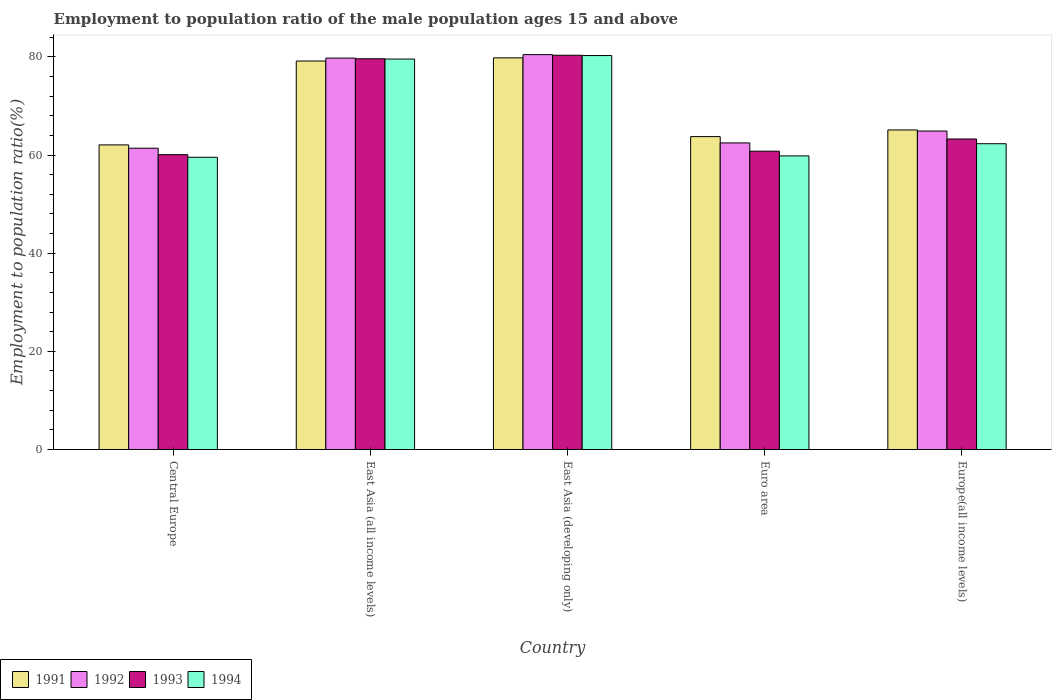How many different coloured bars are there?
Ensure brevity in your answer.  4. Are the number of bars per tick equal to the number of legend labels?
Your answer should be compact. Yes. In how many cases, is the number of bars for a given country not equal to the number of legend labels?
Offer a very short reply. 0. What is the employment to population ratio in 1993 in Euro area?
Your response must be concise. 60.78. Across all countries, what is the maximum employment to population ratio in 1994?
Provide a short and direct response. 80.26. Across all countries, what is the minimum employment to population ratio in 1991?
Provide a short and direct response. 62.06. In which country was the employment to population ratio in 1992 maximum?
Keep it short and to the point. East Asia (developing only). In which country was the employment to population ratio in 1992 minimum?
Ensure brevity in your answer.  Central Europe. What is the total employment to population ratio in 1992 in the graph?
Offer a terse response. 348.92. What is the difference between the employment to population ratio in 1994 in Central Europe and that in Euro area?
Offer a terse response. -0.28. What is the difference between the employment to population ratio in 1992 in East Asia (all income levels) and the employment to population ratio in 1991 in Central Europe?
Your response must be concise. 17.68. What is the average employment to population ratio in 1991 per country?
Give a very brief answer. 69.97. What is the difference between the employment to population ratio of/in 1991 and employment to population ratio of/in 1993 in East Asia (developing only)?
Offer a very short reply. -0.53. What is the ratio of the employment to population ratio in 1991 in East Asia (developing only) to that in Europe(all income levels)?
Your response must be concise. 1.23. Is the difference between the employment to population ratio in 1991 in East Asia (all income levels) and East Asia (developing only) greater than the difference between the employment to population ratio in 1993 in East Asia (all income levels) and East Asia (developing only)?
Offer a very short reply. Yes. What is the difference between the highest and the second highest employment to population ratio in 1991?
Provide a succinct answer. -14.04. What is the difference between the highest and the lowest employment to population ratio in 1993?
Provide a succinct answer. 20.25. Is it the case that in every country, the sum of the employment to population ratio in 1992 and employment to population ratio in 1991 is greater than the sum of employment to population ratio in 1994 and employment to population ratio in 1993?
Your answer should be very brief. No. What does the 4th bar from the left in Euro area represents?
Provide a short and direct response. 1994. Is it the case that in every country, the sum of the employment to population ratio in 1993 and employment to population ratio in 1994 is greater than the employment to population ratio in 1991?
Offer a very short reply. Yes. How many bars are there?
Provide a short and direct response. 20. Are all the bars in the graph horizontal?
Offer a very short reply. No. Are the values on the major ticks of Y-axis written in scientific E-notation?
Offer a terse response. No. What is the title of the graph?
Make the answer very short. Employment to population ratio of the male population ages 15 and above. What is the label or title of the X-axis?
Ensure brevity in your answer.  Country. What is the Employment to population ratio(%) in 1991 in Central Europe?
Offer a very short reply. 62.06. What is the Employment to population ratio(%) in 1992 in Central Europe?
Offer a very short reply. 61.38. What is the Employment to population ratio(%) in 1993 in Central Europe?
Your answer should be very brief. 60.07. What is the Employment to population ratio(%) in 1994 in Central Europe?
Offer a terse response. 59.54. What is the Employment to population ratio(%) of 1991 in East Asia (all income levels)?
Ensure brevity in your answer.  79.15. What is the Employment to population ratio(%) of 1992 in East Asia (all income levels)?
Provide a short and direct response. 79.74. What is the Employment to population ratio(%) of 1993 in East Asia (all income levels)?
Ensure brevity in your answer.  79.61. What is the Employment to population ratio(%) of 1994 in East Asia (all income levels)?
Provide a short and direct response. 79.55. What is the Employment to population ratio(%) in 1991 in East Asia (developing only)?
Offer a terse response. 79.79. What is the Employment to population ratio(%) of 1992 in East Asia (developing only)?
Give a very brief answer. 80.45. What is the Employment to population ratio(%) in 1993 in East Asia (developing only)?
Provide a succinct answer. 80.32. What is the Employment to population ratio(%) in 1994 in East Asia (developing only)?
Your answer should be compact. 80.26. What is the Employment to population ratio(%) of 1991 in Euro area?
Your answer should be compact. 63.75. What is the Employment to population ratio(%) in 1992 in Euro area?
Give a very brief answer. 62.46. What is the Employment to population ratio(%) in 1993 in Euro area?
Provide a short and direct response. 60.78. What is the Employment to population ratio(%) of 1994 in Euro area?
Provide a short and direct response. 59.81. What is the Employment to population ratio(%) in 1991 in Europe(all income levels)?
Keep it short and to the point. 65.11. What is the Employment to population ratio(%) of 1992 in Europe(all income levels)?
Keep it short and to the point. 64.88. What is the Employment to population ratio(%) of 1993 in Europe(all income levels)?
Give a very brief answer. 63.26. What is the Employment to population ratio(%) of 1994 in Europe(all income levels)?
Give a very brief answer. 62.3. Across all countries, what is the maximum Employment to population ratio(%) of 1991?
Ensure brevity in your answer.  79.79. Across all countries, what is the maximum Employment to population ratio(%) in 1992?
Your answer should be very brief. 80.45. Across all countries, what is the maximum Employment to population ratio(%) of 1993?
Your response must be concise. 80.32. Across all countries, what is the maximum Employment to population ratio(%) in 1994?
Your answer should be very brief. 80.26. Across all countries, what is the minimum Employment to population ratio(%) in 1991?
Your response must be concise. 62.06. Across all countries, what is the minimum Employment to population ratio(%) of 1992?
Keep it short and to the point. 61.38. Across all countries, what is the minimum Employment to population ratio(%) in 1993?
Your answer should be compact. 60.07. Across all countries, what is the minimum Employment to population ratio(%) of 1994?
Make the answer very short. 59.54. What is the total Employment to population ratio(%) in 1991 in the graph?
Your response must be concise. 349.86. What is the total Employment to population ratio(%) in 1992 in the graph?
Give a very brief answer. 348.92. What is the total Employment to population ratio(%) in 1993 in the graph?
Offer a very short reply. 344.05. What is the total Employment to population ratio(%) of 1994 in the graph?
Keep it short and to the point. 341.46. What is the difference between the Employment to population ratio(%) of 1991 in Central Europe and that in East Asia (all income levels)?
Offer a terse response. -17.08. What is the difference between the Employment to population ratio(%) of 1992 in Central Europe and that in East Asia (all income levels)?
Ensure brevity in your answer.  -18.36. What is the difference between the Employment to population ratio(%) of 1993 in Central Europe and that in East Asia (all income levels)?
Your answer should be very brief. -19.54. What is the difference between the Employment to population ratio(%) in 1994 in Central Europe and that in East Asia (all income levels)?
Offer a very short reply. -20.01. What is the difference between the Employment to population ratio(%) of 1991 in Central Europe and that in East Asia (developing only)?
Provide a short and direct response. -17.73. What is the difference between the Employment to population ratio(%) in 1992 in Central Europe and that in East Asia (developing only)?
Offer a terse response. -19.07. What is the difference between the Employment to population ratio(%) in 1993 in Central Europe and that in East Asia (developing only)?
Keep it short and to the point. -20.25. What is the difference between the Employment to population ratio(%) of 1994 in Central Europe and that in East Asia (developing only)?
Make the answer very short. -20.72. What is the difference between the Employment to population ratio(%) in 1991 in Central Europe and that in Euro area?
Your answer should be very brief. -1.69. What is the difference between the Employment to population ratio(%) of 1992 in Central Europe and that in Euro area?
Keep it short and to the point. -1.08. What is the difference between the Employment to population ratio(%) in 1993 in Central Europe and that in Euro area?
Offer a very short reply. -0.71. What is the difference between the Employment to population ratio(%) of 1994 in Central Europe and that in Euro area?
Offer a terse response. -0.28. What is the difference between the Employment to population ratio(%) in 1991 in Central Europe and that in Europe(all income levels)?
Your answer should be very brief. -3.04. What is the difference between the Employment to population ratio(%) in 1992 in Central Europe and that in Europe(all income levels)?
Keep it short and to the point. -3.5. What is the difference between the Employment to population ratio(%) in 1993 in Central Europe and that in Europe(all income levels)?
Your answer should be very brief. -3.19. What is the difference between the Employment to population ratio(%) of 1994 in Central Europe and that in Europe(all income levels)?
Give a very brief answer. -2.76. What is the difference between the Employment to population ratio(%) of 1991 in East Asia (all income levels) and that in East Asia (developing only)?
Your answer should be compact. -0.65. What is the difference between the Employment to population ratio(%) of 1992 in East Asia (all income levels) and that in East Asia (developing only)?
Give a very brief answer. -0.71. What is the difference between the Employment to population ratio(%) of 1993 in East Asia (all income levels) and that in East Asia (developing only)?
Ensure brevity in your answer.  -0.72. What is the difference between the Employment to population ratio(%) in 1994 in East Asia (all income levels) and that in East Asia (developing only)?
Offer a terse response. -0.71. What is the difference between the Employment to population ratio(%) in 1991 in East Asia (all income levels) and that in Euro area?
Your answer should be very brief. 15.4. What is the difference between the Employment to population ratio(%) in 1992 in East Asia (all income levels) and that in Euro area?
Offer a terse response. 17.28. What is the difference between the Employment to population ratio(%) of 1993 in East Asia (all income levels) and that in Euro area?
Offer a very short reply. 18.83. What is the difference between the Employment to population ratio(%) in 1994 in East Asia (all income levels) and that in Euro area?
Ensure brevity in your answer.  19.73. What is the difference between the Employment to population ratio(%) of 1991 in East Asia (all income levels) and that in Europe(all income levels)?
Provide a succinct answer. 14.04. What is the difference between the Employment to population ratio(%) in 1992 in East Asia (all income levels) and that in Europe(all income levels)?
Provide a short and direct response. 14.86. What is the difference between the Employment to population ratio(%) in 1993 in East Asia (all income levels) and that in Europe(all income levels)?
Ensure brevity in your answer.  16.34. What is the difference between the Employment to population ratio(%) in 1994 in East Asia (all income levels) and that in Europe(all income levels)?
Give a very brief answer. 17.25. What is the difference between the Employment to population ratio(%) of 1991 in East Asia (developing only) and that in Euro area?
Provide a succinct answer. 16.05. What is the difference between the Employment to population ratio(%) in 1992 in East Asia (developing only) and that in Euro area?
Provide a succinct answer. 17.99. What is the difference between the Employment to population ratio(%) of 1993 in East Asia (developing only) and that in Euro area?
Provide a short and direct response. 19.54. What is the difference between the Employment to population ratio(%) of 1994 in East Asia (developing only) and that in Euro area?
Keep it short and to the point. 20.45. What is the difference between the Employment to population ratio(%) of 1991 in East Asia (developing only) and that in Europe(all income levels)?
Offer a terse response. 14.69. What is the difference between the Employment to population ratio(%) of 1992 in East Asia (developing only) and that in Europe(all income levels)?
Offer a very short reply. 15.57. What is the difference between the Employment to population ratio(%) in 1993 in East Asia (developing only) and that in Europe(all income levels)?
Your answer should be very brief. 17.06. What is the difference between the Employment to population ratio(%) in 1994 in East Asia (developing only) and that in Europe(all income levels)?
Ensure brevity in your answer.  17.96. What is the difference between the Employment to population ratio(%) of 1991 in Euro area and that in Europe(all income levels)?
Give a very brief answer. -1.36. What is the difference between the Employment to population ratio(%) in 1992 in Euro area and that in Europe(all income levels)?
Your response must be concise. -2.42. What is the difference between the Employment to population ratio(%) in 1993 in Euro area and that in Europe(all income levels)?
Keep it short and to the point. -2.48. What is the difference between the Employment to population ratio(%) in 1994 in Euro area and that in Europe(all income levels)?
Your response must be concise. -2.49. What is the difference between the Employment to population ratio(%) in 1991 in Central Europe and the Employment to population ratio(%) in 1992 in East Asia (all income levels)?
Your response must be concise. -17.68. What is the difference between the Employment to population ratio(%) of 1991 in Central Europe and the Employment to population ratio(%) of 1993 in East Asia (all income levels)?
Make the answer very short. -17.55. What is the difference between the Employment to population ratio(%) in 1991 in Central Europe and the Employment to population ratio(%) in 1994 in East Asia (all income levels)?
Your answer should be very brief. -17.49. What is the difference between the Employment to population ratio(%) in 1992 in Central Europe and the Employment to population ratio(%) in 1993 in East Asia (all income levels)?
Ensure brevity in your answer.  -18.22. What is the difference between the Employment to population ratio(%) in 1992 in Central Europe and the Employment to population ratio(%) in 1994 in East Asia (all income levels)?
Offer a terse response. -18.16. What is the difference between the Employment to population ratio(%) of 1993 in Central Europe and the Employment to population ratio(%) of 1994 in East Asia (all income levels)?
Offer a very short reply. -19.48. What is the difference between the Employment to population ratio(%) in 1991 in Central Europe and the Employment to population ratio(%) in 1992 in East Asia (developing only)?
Ensure brevity in your answer.  -18.39. What is the difference between the Employment to population ratio(%) in 1991 in Central Europe and the Employment to population ratio(%) in 1993 in East Asia (developing only)?
Ensure brevity in your answer.  -18.26. What is the difference between the Employment to population ratio(%) of 1991 in Central Europe and the Employment to population ratio(%) of 1994 in East Asia (developing only)?
Your answer should be compact. -18.2. What is the difference between the Employment to population ratio(%) of 1992 in Central Europe and the Employment to population ratio(%) of 1993 in East Asia (developing only)?
Provide a succinct answer. -18.94. What is the difference between the Employment to population ratio(%) in 1992 in Central Europe and the Employment to population ratio(%) in 1994 in East Asia (developing only)?
Provide a short and direct response. -18.88. What is the difference between the Employment to population ratio(%) in 1993 in Central Europe and the Employment to population ratio(%) in 1994 in East Asia (developing only)?
Ensure brevity in your answer.  -20.19. What is the difference between the Employment to population ratio(%) of 1991 in Central Europe and the Employment to population ratio(%) of 1992 in Euro area?
Give a very brief answer. -0.4. What is the difference between the Employment to population ratio(%) of 1991 in Central Europe and the Employment to population ratio(%) of 1993 in Euro area?
Offer a terse response. 1.28. What is the difference between the Employment to population ratio(%) of 1991 in Central Europe and the Employment to population ratio(%) of 1994 in Euro area?
Keep it short and to the point. 2.25. What is the difference between the Employment to population ratio(%) of 1992 in Central Europe and the Employment to population ratio(%) of 1993 in Euro area?
Provide a succinct answer. 0.6. What is the difference between the Employment to population ratio(%) in 1992 in Central Europe and the Employment to population ratio(%) in 1994 in Euro area?
Make the answer very short. 1.57. What is the difference between the Employment to population ratio(%) of 1993 in Central Europe and the Employment to population ratio(%) of 1994 in Euro area?
Your response must be concise. 0.26. What is the difference between the Employment to population ratio(%) in 1991 in Central Europe and the Employment to population ratio(%) in 1992 in Europe(all income levels)?
Give a very brief answer. -2.82. What is the difference between the Employment to population ratio(%) in 1991 in Central Europe and the Employment to population ratio(%) in 1993 in Europe(all income levels)?
Your answer should be very brief. -1.2. What is the difference between the Employment to population ratio(%) in 1991 in Central Europe and the Employment to population ratio(%) in 1994 in Europe(all income levels)?
Offer a terse response. -0.24. What is the difference between the Employment to population ratio(%) of 1992 in Central Europe and the Employment to population ratio(%) of 1993 in Europe(all income levels)?
Provide a short and direct response. -1.88. What is the difference between the Employment to population ratio(%) in 1992 in Central Europe and the Employment to population ratio(%) in 1994 in Europe(all income levels)?
Give a very brief answer. -0.92. What is the difference between the Employment to population ratio(%) in 1993 in Central Europe and the Employment to population ratio(%) in 1994 in Europe(all income levels)?
Provide a short and direct response. -2.23. What is the difference between the Employment to population ratio(%) of 1991 in East Asia (all income levels) and the Employment to population ratio(%) of 1992 in East Asia (developing only)?
Your answer should be compact. -1.3. What is the difference between the Employment to population ratio(%) in 1991 in East Asia (all income levels) and the Employment to population ratio(%) in 1993 in East Asia (developing only)?
Ensure brevity in your answer.  -1.18. What is the difference between the Employment to population ratio(%) in 1991 in East Asia (all income levels) and the Employment to population ratio(%) in 1994 in East Asia (developing only)?
Your answer should be compact. -1.11. What is the difference between the Employment to population ratio(%) of 1992 in East Asia (all income levels) and the Employment to population ratio(%) of 1993 in East Asia (developing only)?
Give a very brief answer. -0.58. What is the difference between the Employment to population ratio(%) in 1992 in East Asia (all income levels) and the Employment to population ratio(%) in 1994 in East Asia (developing only)?
Your response must be concise. -0.52. What is the difference between the Employment to population ratio(%) in 1993 in East Asia (all income levels) and the Employment to population ratio(%) in 1994 in East Asia (developing only)?
Offer a very short reply. -0.65. What is the difference between the Employment to population ratio(%) of 1991 in East Asia (all income levels) and the Employment to population ratio(%) of 1992 in Euro area?
Give a very brief answer. 16.68. What is the difference between the Employment to population ratio(%) of 1991 in East Asia (all income levels) and the Employment to population ratio(%) of 1993 in Euro area?
Your answer should be very brief. 18.37. What is the difference between the Employment to population ratio(%) in 1991 in East Asia (all income levels) and the Employment to population ratio(%) in 1994 in Euro area?
Your answer should be compact. 19.33. What is the difference between the Employment to population ratio(%) of 1992 in East Asia (all income levels) and the Employment to population ratio(%) of 1993 in Euro area?
Keep it short and to the point. 18.96. What is the difference between the Employment to population ratio(%) of 1992 in East Asia (all income levels) and the Employment to population ratio(%) of 1994 in Euro area?
Keep it short and to the point. 19.93. What is the difference between the Employment to population ratio(%) of 1993 in East Asia (all income levels) and the Employment to population ratio(%) of 1994 in Euro area?
Make the answer very short. 19.79. What is the difference between the Employment to population ratio(%) of 1991 in East Asia (all income levels) and the Employment to population ratio(%) of 1992 in Europe(all income levels)?
Offer a terse response. 14.26. What is the difference between the Employment to population ratio(%) of 1991 in East Asia (all income levels) and the Employment to population ratio(%) of 1993 in Europe(all income levels)?
Keep it short and to the point. 15.88. What is the difference between the Employment to population ratio(%) in 1991 in East Asia (all income levels) and the Employment to population ratio(%) in 1994 in Europe(all income levels)?
Give a very brief answer. 16.85. What is the difference between the Employment to population ratio(%) of 1992 in East Asia (all income levels) and the Employment to population ratio(%) of 1993 in Europe(all income levels)?
Ensure brevity in your answer.  16.48. What is the difference between the Employment to population ratio(%) in 1992 in East Asia (all income levels) and the Employment to population ratio(%) in 1994 in Europe(all income levels)?
Your response must be concise. 17.44. What is the difference between the Employment to population ratio(%) of 1993 in East Asia (all income levels) and the Employment to population ratio(%) of 1994 in Europe(all income levels)?
Provide a short and direct response. 17.31. What is the difference between the Employment to population ratio(%) in 1991 in East Asia (developing only) and the Employment to population ratio(%) in 1992 in Euro area?
Your response must be concise. 17.33. What is the difference between the Employment to population ratio(%) of 1991 in East Asia (developing only) and the Employment to population ratio(%) of 1993 in Euro area?
Offer a very short reply. 19.01. What is the difference between the Employment to population ratio(%) of 1991 in East Asia (developing only) and the Employment to population ratio(%) of 1994 in Euro area?
Provide a succinct answer. 19.98. What is the difference between the Employment to population ratio(%) in 1992 in East Asia (developing only) and the Employment to population ratio(%) in 1993 in Euro area?
Offer a terse response. 19.67. What is the difference between the Employment to population ratio(%) in 1992 in East Asia (developing only) and the Employment to population ratio(%) in 1994 in Euro area?
Provide a short and direct response. 20.64. What is the difference between the Employment to population ratio(%) in 1993 in East Asia (developing only) and the Employment to population ratio(%) in 1994 in Euro area?
Offer a very short reply. 20.51. What is the difference between the Employment to population ratio(%) in 1991 in East Asia (developing only) and the Employment to population ratio(%) in 1992 in Europe(all income levels)?
Ensure brevity in your answer.  14.91. What is the difference between the Employment to population ratio(%) in 1991 in East Asia (developing only) and the Employment to population ratio(%) in 1993 in Europe(all income levels)?
Make the answer very short. 16.53. What is the difference between the Employment to population ratio(%) in 1991 in East Asia (developing only) and the Employment to population ratio(%) in 1994 in Europe(all income levels)?
Your answer should be compact. 17.49. What is the difference between the Employment to population ratio(%) of 1992 in East Asia (developing only) and the Employment to population ratio(%) of 1993 in Europe(all income levels)?
Offer a terse response. 17.19. What is the difference between the Employment to population ratio(%) of 1992 in East Asia (developing only) and the Employment to population ratio(%) of 1994 in Europe(all income levels)?
Offer a terse response. 18.15. What is the difference between the Employment to population ratio(%) in 1993 in East Asia (developing only) and the Employment to population ratio(%) in 1994 in Europe(all income levels)?
Your answer should be very brief. 18.02. What is the difference between the Employment to population ratio(%) in 1991 in Euro area and the Employment to population ratio(%) in 1992 in Europe(all income levels)?
Your answer should be very brief. -1.14. What is the difference between the Employment to population ratio(%) of 1991 in Euro area and the Employment to population ratio(%) of 1993 in Europe(all income levels)?
Provide a short and direct response. 0.48. What is the difference between the Employment to population ratio(%) in 1991 in Euro area and the Employment to population ratio(%) in 1994 in Europe(all income levels)?
Your response must be concise. 1.45. What is the difference between the Employment to population ratio(%) of 1992 in Euro area and the Employment to population ratio(%) of 1993 in Europe(all income levels)?
Your answer should be very brief. -0.8. What is the difference between the Employment to population ratio(%) of 1992 in Euro area and the Employment to population ratio(%) of 1994 in Europe(all income levels)?
Keep it short and to the point. 0.16. What is the difference between the Employment to population ratio(%) of 1993 in Euro area and the Employment to population ratio(%) of 1994 in Europe(all income levels)?
Give a very brief answer. -1.52. What is the average Employment to population ratio(%) in 1991 per country?
Ensure brevity in your answer.  69.97. What is the average Employment to population ratio(%) in 1992 per country?
Make the answer very short. 69.78. What is the average Employment to population ratio(%) of 1993 per country?
Keep it short and to the point. 68.81. What is the average Employment to population ratio(%) of 1994 per country?
Your answer should be very brief. 68.29. What is the difference between the Employment to population ratio(%) in 1991 and Employment to population ratio(%) in 1992 in Central Europe?
Give a very brief answer. 0.68. What is the difference between the Employment to population ratio(%) in 1991 and Employment to population ratio(%) in 1993 in Central Europe?
Your answer should be compact. 1.99. What is the difference between the Employment to population ratio(%) of 1991 and Employment to population ratio(%) of 1994 in Central Europe?
Make the answer very short. 2.52. What is the difference between the Employment to population ratio(%) in 1992 and Employment to population ratio(%) in 1993 in Central Europe?
Provide a succinct answer. 1.31. What is the difference between the Employment to population ratio(%) of 1992 and Employment to population ratio(%) of 1994 in Central Europe?
Your answer should be very brief. 1.85. What is the difference between the Employment to population ratio(%) in 1993 and Employment to population ratio(%) in 1994 in Central Europe?
Provide a short and direct response. 0.53. What is the difference between the Employment to population ratio(%) in 1991 and Employment to population ratio(%) in 1992 in East Asia (all income levels)?
Make the answer very short. -0.59. What is the difference between the Employment to population ratio(%) of 1991 and Employment to population ratio(%) of 1993 in East Asia (all income levels)?
Provide a succinct answer. -0.46. What is the difference between the Employment to population ratio(%) in 1991 and Employment to population ratio(%) in 1994 in East Asia (all income levels)?
Make the answer very short. -0.4. What is the difference between the Employment to population ratio(%) in 1992 and Employment to population ratio(%) in 1993 in East Asia (all income levels)?
Your response must be concise. 0.13. What is the difference between the Employment to population ratio(%) of 1992 and Employment to population ratio(%) of 1994 in East Asia (all income levels)?
Your answer should be very brief. 0.19. What is the difference between the Employment to population ratio(%) of 1993 and Employment to population ratio(%) of 1994 in East Asia (all income levels)?
Provide a short and direct response. 0.06. What is the difference between the Employment to population ratio(%) of 1991 and Employment to population ratio(%) of 1992 in East Asia (developing only)?
Your response must be concise. -0.66. What is the difference between the Employment to population ratio(%) of 1991 and Employment to population ratio(%) of 1993 in East Asia (developing only)?
Make the answer very short. -0.53. What is the difference between the Employment to population ratio(%) of 1991 and Employment to population ratio(%) of 1994 in East Asia (developing only)?
Give a very brief answer. -0.47. What is the difference between the Employment to population ratio(%) in 1992 and Employment to population ratio(%) in 1993 in East Asia (developing only)?
Your answer should be very brief. 0.13. What is the difference between the Employment to population ratio(%) in 1992 and Employment to population ratio(%) in 1994 in East Asia (developing only)?
Offer a terse response. 0.19. What is the difference between the Employment to population ratio(%) in 1993 and Employment to population ratio(%) in 1994 in East Asia (developing only)?
Offer a very short reply. 0.06. What is the difference between the Employment to population ratio(%) of 1991 and Employment to population ratio(%) of 1992 in Euro area?
Your response must be concise. 1.29. What is the difference between the Employment to population ratio(%) in 1991 and Employment to population ratio(%) in 1993 in Euro area?
Provide a succinct answer. 2.97. What is the difference between the Employment to population ratio(%) in 1991 and Employment to population ratio(%) in 1994 in Euro area?
Offer a terse response. 3.93. What is the difference between the Employment to population ratio(%) of 1992 and Employment to population ratio(%) of 1993 in Euro area?
Offer a terse response. 1.68. What is the difference between the Employment to population ratio(%) of 1992 and Employment to population ratio(%) of 1994 in Euro area?
Your answer should be compact. 2.65. What is the difference between the Employment to population ratio(%) of 1993 and Employment to population ratio(%) of 1994 in Euro area?
Your response must be concise. 0.97. What is the difference between the Employment to population ratio(%) in 1991 and Employment to population ratio(%) in 1992 in Europe(all income levels)?
Provide a short and direct response. 0.22. What is the difference between the Employment to population ratio(%) in 1991 and Employment to population ratio(%) in 1993 in Europe(all income levels)?
Your response must be concise. 1.84. What is the difference between the Employment to population ratio(%) of 1991 and Employment to population ratio(%) of 1994 in Europe(all income levels)?
Make the answer very short. 2.81. What is the difference between the Employment to population ratio(%) of 1992 and Employment to population ratio(%) of 1993 in Europe(all income levels)?
Give a very brief answer. 1.62. What is the difference between the Employment to population ratio(%) in 1992 and Employment to population ratio(%) in 1994 in Europe(all income levels)?
Keep it short and to the point. 2.58. What is the difference between the Employment to population ratio(%) in 1993 and Employment to population ratio(%) in 1994 in Europe(all income levels)?
Offer a very short reply. 0.97. What is the ratio of the Employment to population ratio(%) in 1991 in Central Europe to that in East Asia (all income levels)?
Ensure brevity in your answer.  0.78. What is the ratio of the Employment to population ratio(%) in 1992 in Central Europe to that in East Asia (all income levels)?
Make the answer very short. 0.77. What is the ratio of the Employment to population ratio(%) of 1993 in Central Europe to that in East Asia (all income levels)?
Ensure brevity in your answer.  0.75. What is the ratio of the Employment to population ratio(%) of 1994 in Central Europe to that in East Asia (all income levels)?
Your answer should be very brief. 0.75. What is the ratio of the Employment to population ratio(%) in 1991 in Central Europe to that in East Asia (developing only)?
Provide a short and direct response. 0.78. What is the ratio of the Employment to population ratio(%) in 1992 in Central Europe to that in East Asia (developing only)?
Provide a short and direct response. 0.76. What is the ratio of the Employment to population ratio(%) of 1993 in Central Europe to that in East Asia (developing only)?
Offer a terse response. 0.75. What is the ratio of the Employment to population ratio(%) of 1994 in Central Europe to that in East Asia (developing only)?
Your answer should be compact. 0.74. What is the ratio of the Employment to population ratio(%) in 1991 in Central Europe to that in Euro area?
Provide a succinct answer. 0.97. What is the ratio of the Employment to population ratio(%) in 1992 in Central Europe to that in Euro area?
Your response must be concise. 0.98. What is the ratio of the Employment to population ratio(%) of 1993 in Central Europe to that in Euro area?
Provide a succinct answer. 0.99. What is the ratio of the Employment to population ratio(%) in 1991 in Central Europe to that in Europe(all income levels)?
Provide a succinct answer. 0.95. What is the ratio of the Employment to population ratio(%) in 1992 in Central Europe to that in Europe(all income levels)?
Your answer should be very brief. 0.95. What is the ratio of the Employment to population ratio(%) in 1993 in Central Europe to that in Europe(all income levels)?
Ensure brevity in your answer.  0.95. What is the ratio of the Employment to population ratio(%) in 1994 in Central Europe to that in Europe(all income levels)?
Provide a succinct answer. 0.96. What is the ratio of the Employment to population ratio(%) of 1991 in East Asia (all income levels) to that in East Asia (developing only)?
Give a very brief answer. 0.99. What is the ratio of the Employment to population ratio(%) in 1992 in East Asia (all income levels) to that in East Asia (developing only)?
Make the answer very short. 0.99. What is the ratio of the Employment to population ratio(%) in 1993 in East Asia (all income levels) to that in East Asia (developing only)?
Your answer should be very brief. 0.99. What is the ratio of the Employment to population ratio(%) in 1991 in East Asia (all income levels) to that in Euro area?
Offer a terse response. 1.24. What is the ratio of the Employment to population ratio(%) in 1992 in East Asia (all income levels) to that in Euro area?
Give a very brief answer. 1.28. What is the ratio of the Employment to population ratio(%) in 1993 in East Asia (all income levels) to that in Euro area?
Offer a very short reply. 1.31. What is the ratio of the Employment to population ratio(%) in 1994 in East Asia (all income levels) to that in Euro area?
Ensure brevity in your answer.  1.33. What is the ratio of the Employment to population ratio(%) in 1991 in East Asia (all income levels) to that in Europe(all income levels)?
Your response must be concise. 1.22. What is the ratio of the Employment to population ratio(%) of 1992 in East Asia (all income levels) to that in Europe(all income levels)?
Ensure brevity in your answer.  1.23. What is the ratio of the Employment to population ratio(%) in 1993 in East Asia (all income levels) to that in Europe(all income levels)?
Offer a very short reply. 1.26. What is the ratio of the Employment to population ratio(%) of 1994 in East Asia (all income levels) to that in Europe(all income levels)?
Ensure brevity in your answer.  1.28. What is the ratio of the Employment to population ratio(%) in 1991 in East Asia (developing only) to that in Euro area?
Keep it short and to the point. 1.25. What is the ratio of the Employment to population ratio(%) of 1992 in East Asia (developing only) to that in Euro area?
Make the answer very short. 1.29. What is the ratio of the Employment to population ratio(%) in 1993 in East Asia (developing only) to that in Euro area?
Provide a succinct answer. 1.32. What is the ratio of the Employment to population ratio(%) in 1994 in East Asia (developing only) to that in Euro area?
Your response must be concise. 1.34. What is the ratio of the Employment to population ratio(%) of 1991 in East Asia (developing only) to that in Europe(all income levels)?
Your response must be concise. 1.23. What is the ratio of the Employment to population ratio(%) in 1992 in East Asia (developing only) to that in Europe(all income levels)?
Offer a terse response. 1.24. What is the ratio of the Employment to population ratio(%) of 1993 in East Asia (developing only) to that in Europe(all income levels)?
Your response must be concise. 1.27. What is the ratio of the Employment to population ratio(%) in 1994 in East Asia (developing only) to that in Europe(all income levels)?
Your response must be concise. 1.29. What is the ratio of the Employment to population ratio(%) of 1991 in Euro area to that in Europe(all income levels)?
Your answer should be very brief. 0.98. What is the ratio of the Employment to population ratio(%) of 1992 in Euro area to that in Europe(all income levels)?
Your answer should be very brief. 0.96. What is the ratio of the Employment to population ratio(%) in 1993 in Euro area to that in Europe(all income levels)?
Provide a short and direct response. 0.96. What is the ratio of the Employment to population ratio(%) of 1994 in Euro area to that in Europe(all income levels)?
Ensure brevity in your answer.  0.96. What is the difference between the highest and the second highest Employment to population ratio(%) in 1991?
Give a very brief answer. 0.65. What is the difference between the highest and the second highest Employment to population ratio(%) in 1992?
Provide a short and direct response. 0.71. What is the difference between the highest and the second highest Employment to population ratio(%) of 1993?
Offer a terse response. 0.72. What is the difference between the highest and the second highest Employment to population ratio(%) in 1994?
Provide a succinct answer. 0.71. What is the difference between the highest and the lowest Employment to population ratio(%) in 1991?
Make the answer very short. 17.73. What is the difference between the highest and the lowest Employment to population ratio(%) in 1992?
Offer a very short reply. 19.07. What is the difference between the highest and the lowest Employment to population ratio(%) in 1993?
Provide a short and direct response. 20.25. What is the difference between the highest and the lowest Employment to population ratio(%) of 1994?
Ensure brevity in your answer.  20.72. 